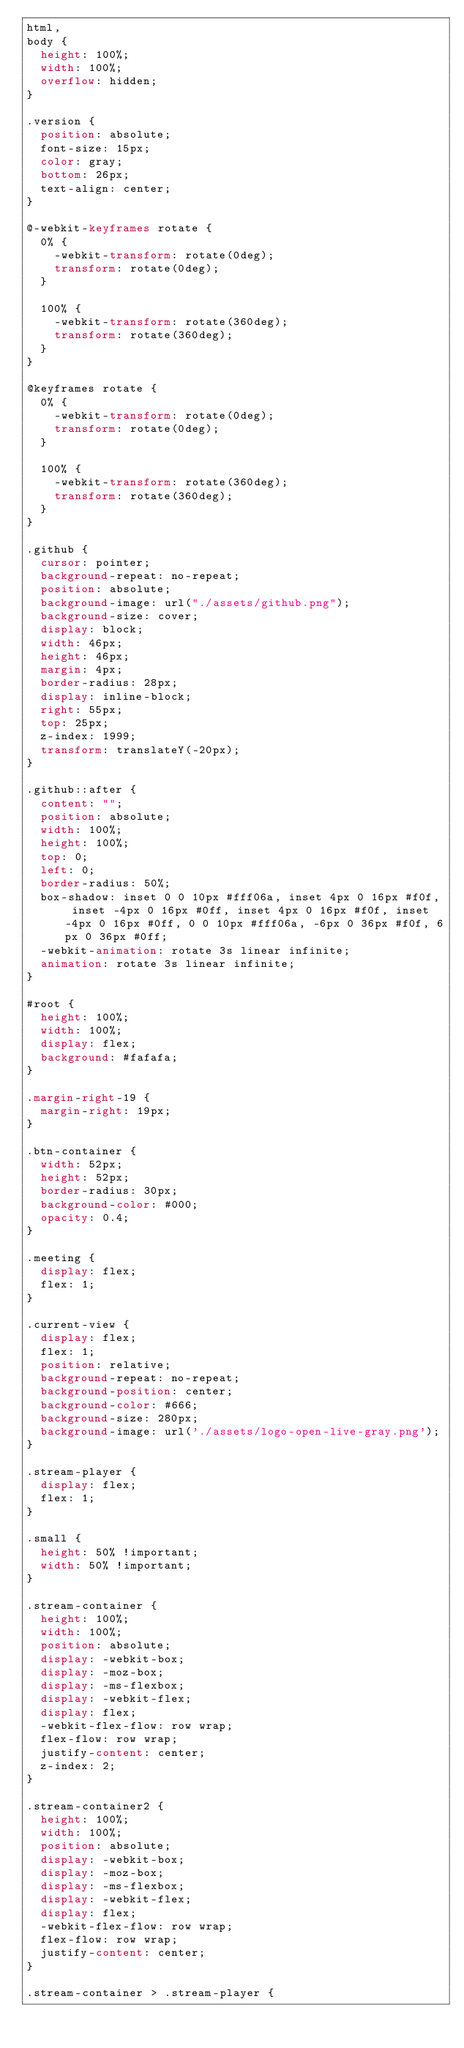<code> <loc_0><loc_0><loc_500><loc_500><_CSS_>html,
body {
  height: 100%;
  width: 100%;
  overflow: hidden;
}

.version {
  position: absolute;
  font-size: 15px;
  color: gray;
  bottom: 26px;
  text-align: center;
}

@-webkit-keyframes rotate {
  0% {
    -webkit-transform: rotate(0deg);
    transform: rotate(0deg);
  }

  100% {
    -webkit-transform: rotate(360deg);
    transform: rotate(360deg);
  }
}

@keyframes rotate {
  0% {
    -webkit-transform: rotate(0deg);
    transform: rotate(0deg);
  }

  100% {
    -webkit-transform: rotate(360deg);
    transform: rotate(360deg);
  }
}

.github {
  cursor: pointer;
  background-repeat: no-repeat;
  position: absolute;
  background-image: url("./assets/github.png");
  background-size: cover;
  display: block;
  width: 46px;
  height: 46px;
  margin: 4px;
  border-radius: 28px;
  display: inline-block;
  right: 55px;
  top: 25px;
  z-index: 1999;
  transform: translateY(-20px);
}

.github::after {
  content: "";
  position: absolute;
  width: 100%;
  height: 100%;
  top: 0;
  left: 0;
  border-radius: 50%;
  box-shadow: inset 0 0 10px #fff06a, inset 4px 0 16px #f0f, inset -4px 0 16px #0ff, inset 4px 0 16px #f0f, inset -4px 0 16px #0ff, 0 0 10px #fff06a, -6px 0 36px #f0f, 6px 0 36px #0ff;
  -webkit-animation: rotate 3s linear infinite;
  animation: rotate 3s linear infinite;
}

#root {
  height: 100%;
  width: 100%;
  display: flex;
  background: #fafafa;
}

.margin-right-19 {
  margin-right: 19px;
}

.btn-container {
  width: 52px;
  height: 52px;
  border-radius: 30px;
  background-color: #000;
  opacity: 0.4;
}

.meeting {
  display: flex;
  flex: 1;
}

.current-view {
  display: flex;
  flex: 1;
  position: relative;
  background-repeat: no-repeat;
  background-position: center;
  background-color: #666;
  background-size: 280px;
  background-image: url('./assets/logo-open-live-gray.png');
}

.stream-player {
  display: flex;
  flex: 1;
}

.small {
  height: 50% !important;
  width: 50% !important;
}

.stream-container {
  height: 100%;
  width: 100%;
  position: absolute;
  display: -webkit-box;
  display: -moz-box;
  display: -ms-flexbox;
  display: -webkit-flex;
  display: flex;
  -webkit-flex-flow: row wrap;
  flex-flow: row wrap;
  justify-content: center;
  z-index: 2;
}

.stream-container2 {
  height: 100%;
  width: 100%;
  position: absolute;
  display: -webkit-box;
  display: -moz-box;
  display: -ms-flexbox;
  display: -webkit-flex;
  display: flex;
  -webkit-flex-flow: row wrap;
  flex-flow: row wrap;
  justify-content: center;
}

.stream-container > .stream-player {</code> 